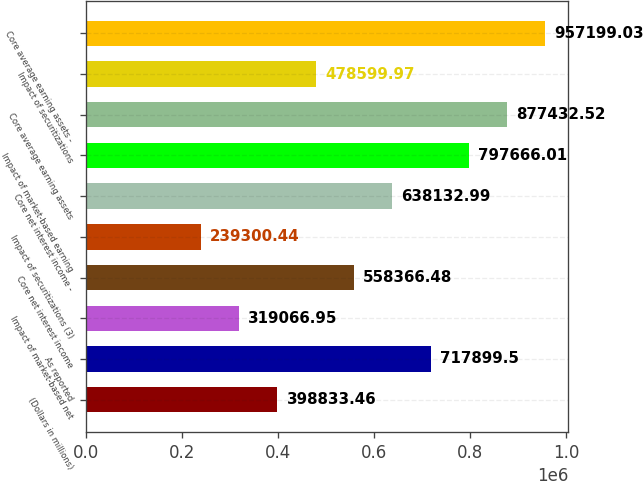<chart> <loc_0><loc_0><loc_500><loc_500><bar_chart><fcel>(Dollars in millions)<fcel>As reported<fcel>Impact of market-based net<fcel>Core net interest income<fcel>Impact of securitizations (3)<fcel>Core net interest income -<fcel>Impact of market-based earning<fcel>Core average earning assets<fcel>Impact of securitizations<fcel>Core average earning assets -<nl><fcel>398833<fcel>717900<fcel>319067<fcel>558366<fcel>239300<fcel>638133<fcel>797666<fcel>877433<fcel>478600<fcel>957199<nl></chart> 